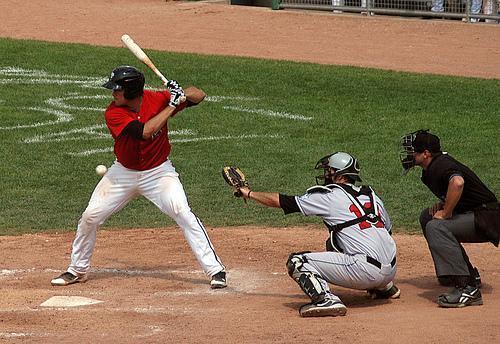How many people are playing football?
Give a very brief answer. 0. 